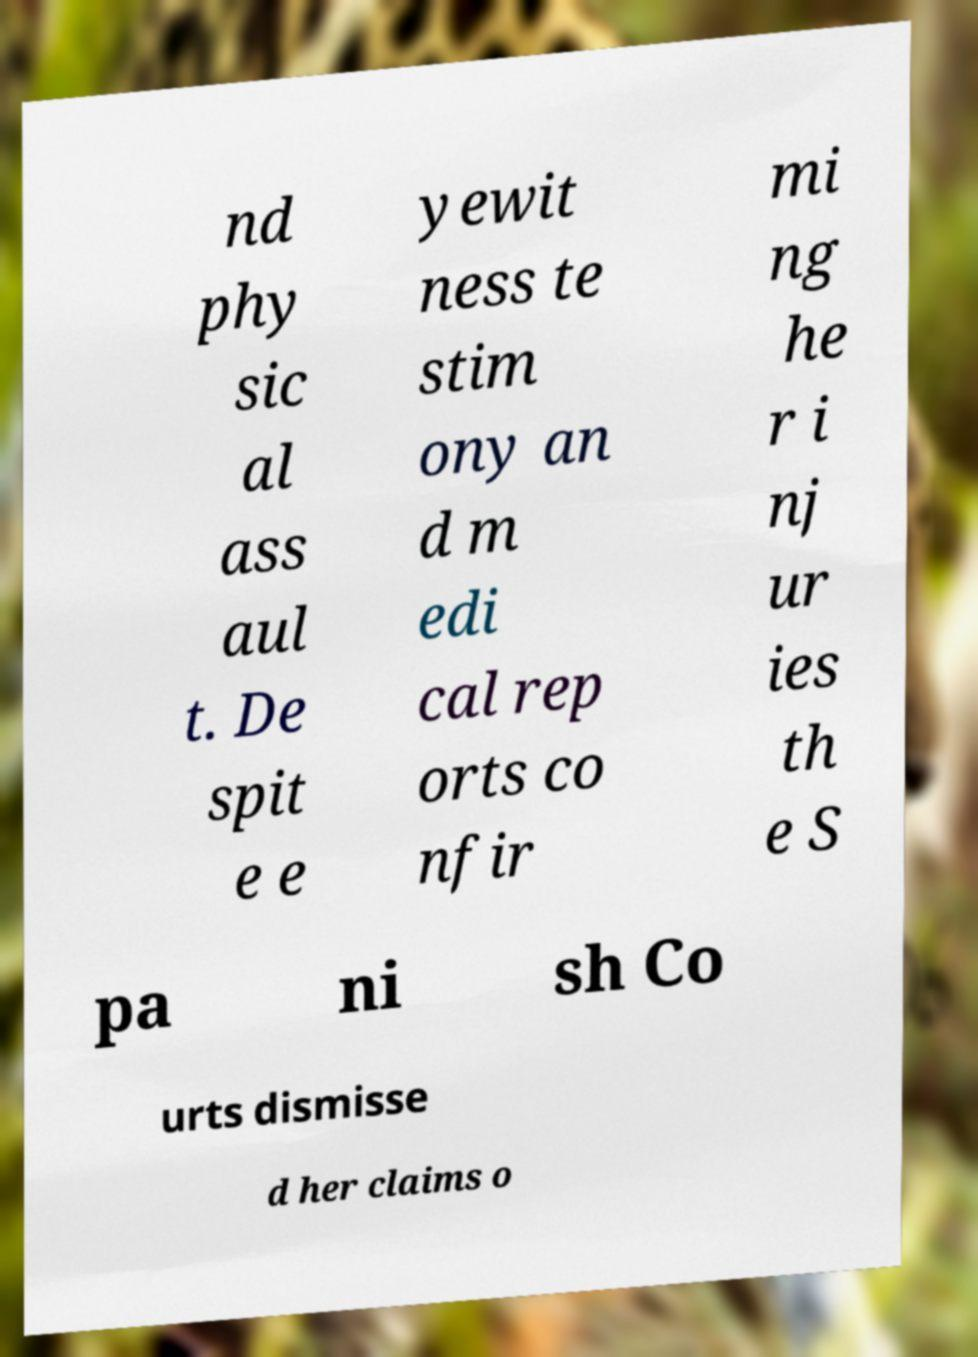Could you extract and type out the text from this image? nd phy sic al ass aul t. De spit e e yewit ness te stim ony an d m edi cal rep orts co nfir mi ng he r i nj ur ies th e S pa ni sh Co urts dismisse d her claims o 